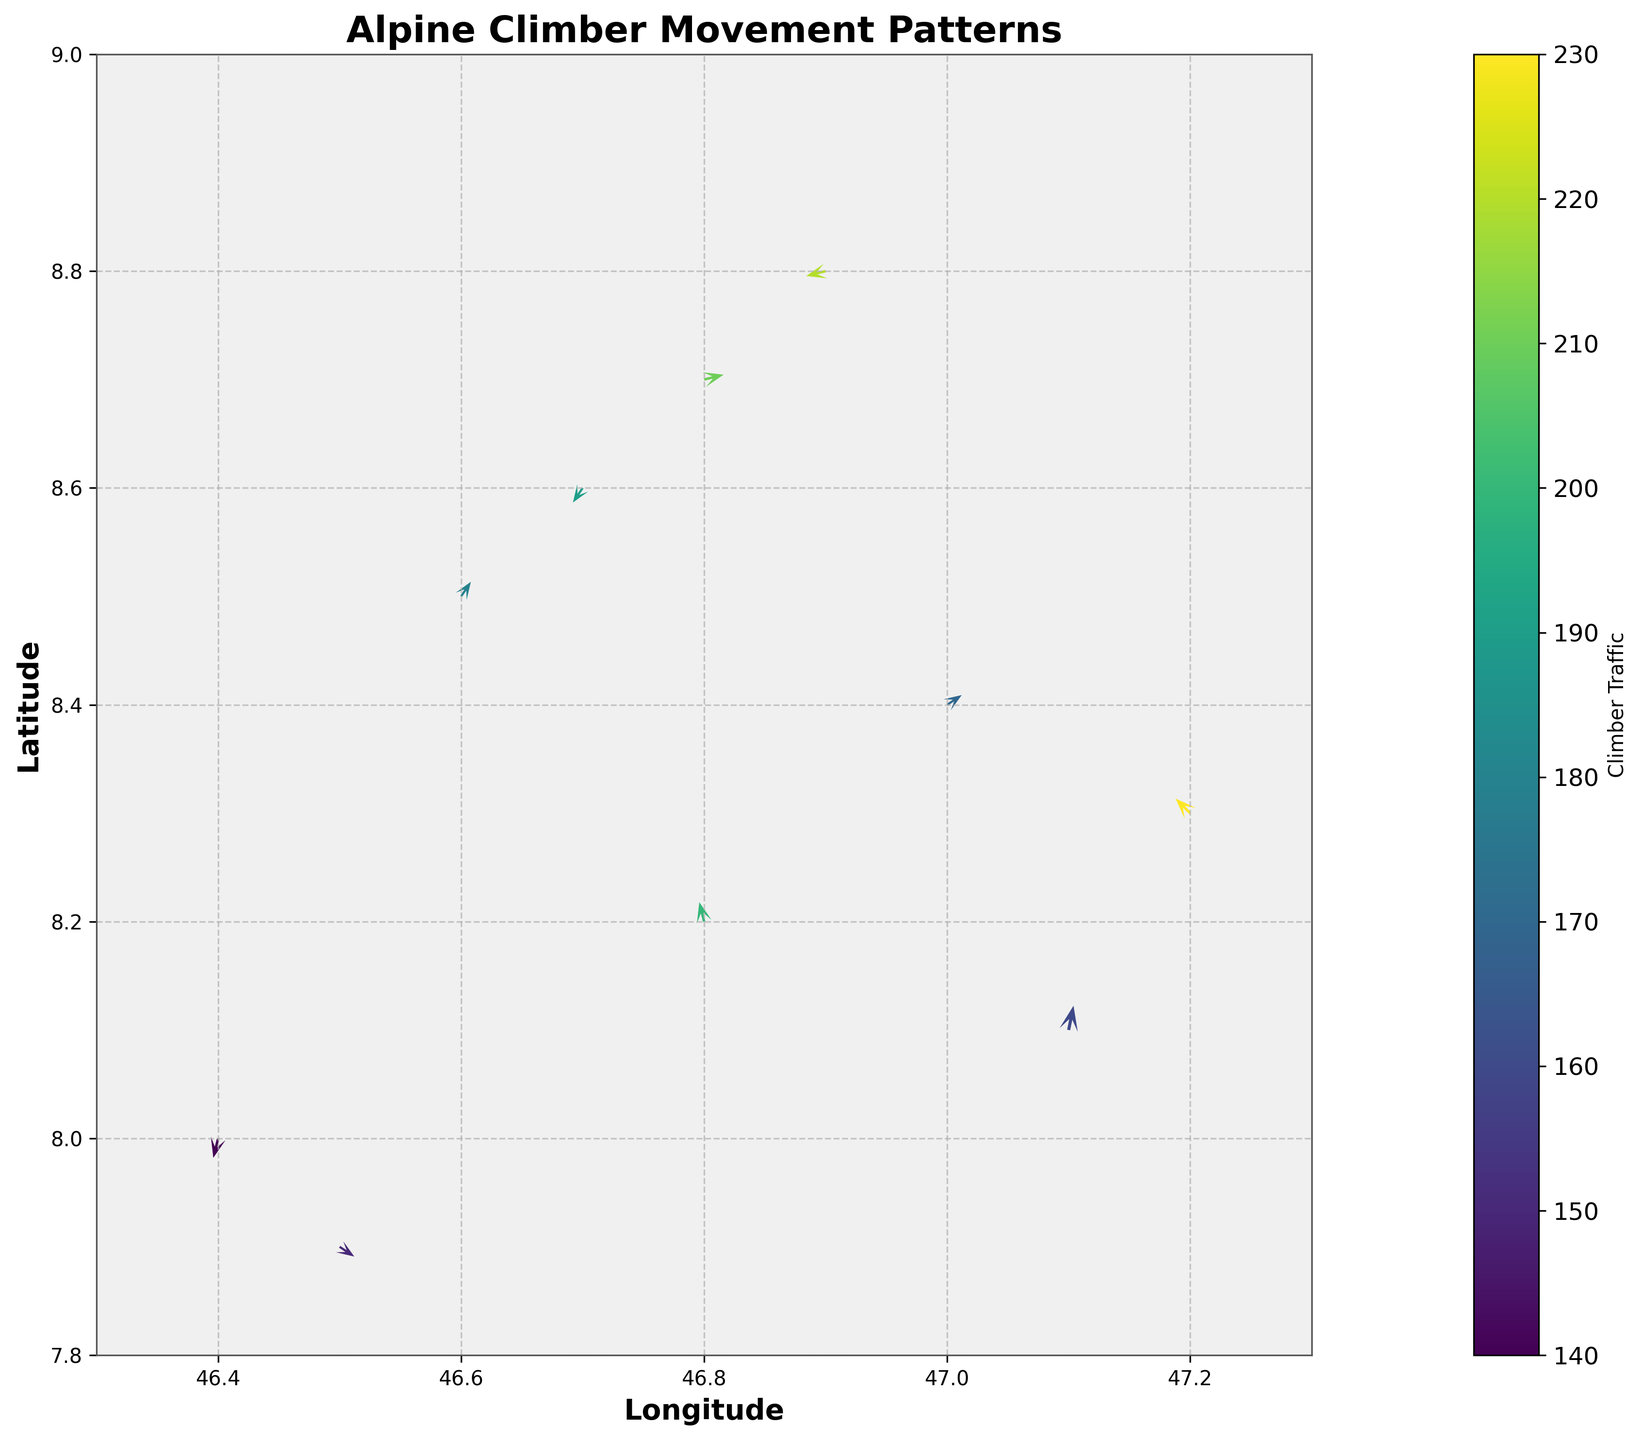How many arrows are plotted on the figure? The number of arrows corresponds to the number of data points, which is 10. Just count the arrows on the quiver plot.
Answer: 10 What is the overall direction of the arrow in the top-right corner? The top-right corner refers to the arrow at (47.2, 8.3). Its direction is determined by its components: u = -0.3 and v = 0.3. This indicates a direction to the left and slightly upward.
Answer: To the left and upward Which data point has the highest climber traffic? From the color scale, the data point with the highest magnitude (230) corresponds to the most intense color on the colormap, situated at (47.2, 8.3).
Answer: (47.2, 8.3) What is the average magnitude of the climber traffic across all points? The magnitudes are 150, 200, 180, 220, 160, 190, 170, 140, 210, 230. Their sum is 1850. Dividing by the number of data points (10), the average magnitude is 185.
Answer: 185 Which location shows the steepest ascent? To find the steepest ascent, we look for the arrow with the largest vertical component. The arrow at (47.1, 8.1) has u = 0.1 and v = 0.5, indicating the steepest upward movement.
Answer: (47.1, 8.1) What are the coordinates of the data point with the lowest traffic concentration? The data point with the lowest magnitude (140) shows the least climber traffic and is at (46.4, 8.0).
Answer: (46.4, 8.0) Compare the arrows at (46.8, 8.2) and (47.0, 8.4), which one is longer? The lengths are determined by the magnitudes. (46.8, 8.2) has a magnitude of 200, and (47.0, 8.4) has 170. Since 200 is greater than 170, the arrow at (46.8, 8.2) is longer.
Answer: (46.8, 8.2) Which direction shows the most diverse movement patterns? The most diverse movement patterns should see arrows pointing in many directions. From the plot, the region around latitudes 8.3 to 8.8 and longitudes 46.7 to 47.2 shows arrows pointing in several directions: right, left, upward, and downward.
Answer: 8.3 to 8.8, 46.7 to 47.2 Is there any region where the movement of climbers is primarily horizontal? The arrows with significant horizontal components (greater u relative to v) can indicate mainly horizontal movement. Locations like (46.8, 8.7) with (u=0.4, v=0.1) show predominantly horizontal movement.
Answer: (46.8, 8.7) Which arrow would indicate a retreat or downward movement? An arrow with a negative vertical component (v) indicates a downward movement. For example, the arrow at (46.7, 8.6) has u = -0.2 and v = -0.3, indicating a retreat or downward direction.
Answer: (46.7, 8.6) 